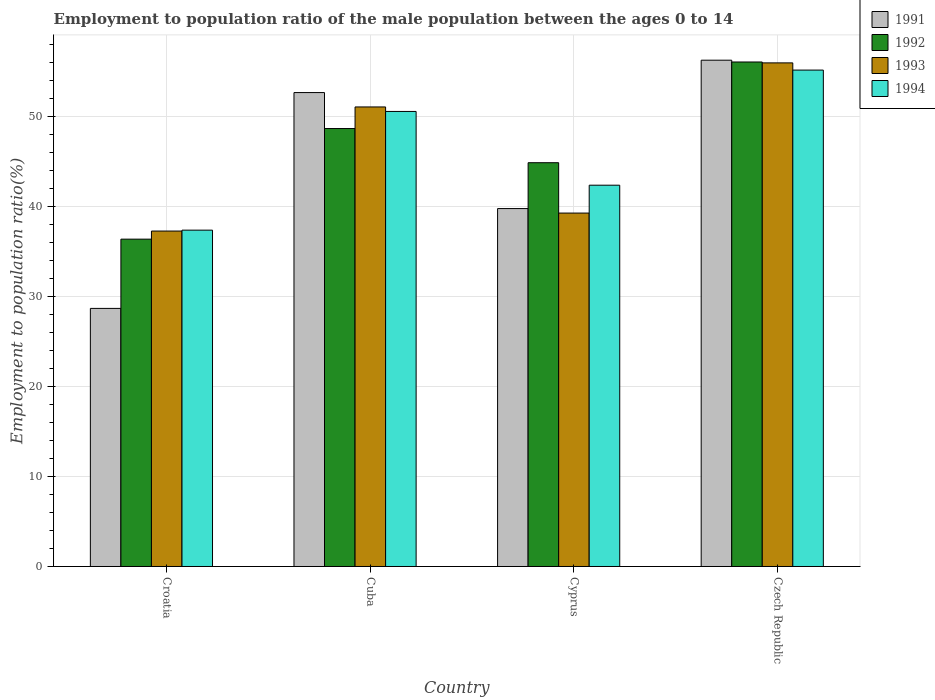How many groups of bars are there?
Your answer should be very brief. 4. Are the number of bars on each tick of the X-axis equal?
Provide a succinct answer. Yes. How many bars are there on the 1st tick from the right?
Offer a terse response. 4. What is the label of the 3rd group of bars from the left?
Offer a very short reply. Cyprus. What is the employment to population ratio in 1993 in Croatia?
Provide a succinct answer. 37.3. Across all countries, what is the maximum employment to population ratio in 1994?
Offer a very short reply. 55.2. Across all countries, what is the minimum employment to population ratio in 1993?
Make the answer very short. 37.3. In which country was the employment to population ratio in 1994 maximum?
Offer a terse response. Czech Republic. In which country was the employment to population ratio in 1993 minimum?
Your answer should be compact. Croatia. What is the total employment to population ratio in 1994 in the graph?
Offer a very short reply. 185.6. What is the difference between the employment to population ratio in 1993 in Cyprus and that in Czech Republic?
Your response must be concise. -16.7. What is the difference between the employment to population ratio in 1994 in Czech Republic and the employment to population ratio in 1991 in Cuba?
Your response must be concise. 2.5. What is the average employment to population ratio in 1992 per country?
Your answer should be very brief. 46.53. What is the difference between the employment to population ratio of/in 1994 and employment to population ratio of/in 1992 in Croatia?
Give a very brief answer. 1. What is the ratio of the employment to population ratio in 1993 in Croatia to that in Cyprus?
Keep it short and to the point. 0.95. Is the employment to population ratio in 1992 in Croatia less than that in Cyprus?
Your answer should be very brief. Yes. Is the difference between the employment to population ratio in 1994 in Cyprus and Czech Republic greater than the difference between the employment to population ratio in 1992 in Cyprus and Czech Republic?
Offer a terse response. No. What is the difference between the highest and the second highest employment to population ratio in 1993?
Provide a short and direct response. 4.9. What is the difference between the highest and the lowest employment to population ratio in 1991?
Provide a succinct answer. 27.6. In how many countries, is the employment to population ratio in 1992 greater than the average employment to population ratio in 1992 taken over all countries?
Your response must be concise. 2. Is it the case that in every country, the sum of the employment to population ratio in 1993 and employment to population ratio in 1994 is greater than the sum of employment to population ratio in 1991 and employment to population ratio in 1992?
Make the answer very short. No. What does the 4th bar from the left in Cyprus represents?
Make the answer very short. 1994. What does the 1st bar from the right in Croatia represents?
Your answer should be compact. 1994. What is the difference between two consecutive major ticks on the Y-axis?
Provide a succinct answer. 10. Does the graph contain any zero values?
Provide a short and direct response. No. How many legend labels are there?
Your answer should be compact. 4. What is the title of the graph?
Your answer should be compact. Employment to population ratio of the male population between the ages 0 to 14. Does "1996" appear as one of the legend labels in the graph?
Ensure brevity in your answer.  No. What is the Employment to population ratio(%) in 1991 in Croatia?
Offer a very short reply. 28.7. What is the Employment to population ratio(%) in 1992 in Croatia?
Provide a short and direct response. 36.4. What is the Employment to population ratio(%) in 1993 in Croatia?
Your answer should be very brief. 37.3. What is the Employment to population ratio(%) of 1994 in Croatia?
Provide a succinct answer. 37.4. What is the Employment to population ratio(%) of 1991 in Cuba?
Provide a succinct answer. 52.7. What is the Employment to population ratio(%) in 1992 in Cuba?
Provide a succinct answer. 48.7. What is the Employment to population ratio(%) in 1993 in Cuba?
Your response must be concise. 51.1. What is the Employment to population ratio(%) of 1994 in Cuba?
Your answer should be compact. 50.6. What is the Employment to population ratio(%) of 1991 in Cyprus?
Your answer should be very brief. 39.8. What is the Employment to population ratio(%) of 1992 in Cyprus?
Give a very brief answer. 44.9. What is the Employment to population ratio(%) in 1993 in Cyprus?
Your answer should be very brief. 39.3. What is the Employment to population ratio(%) in 1994 in Cyprus?
Provide a short and direct response. 42.4. What is the Employment to population ratio(%) in 1991 in Czech Republic?
Provide a short and direct response. 56.3. What is the Employment to population ratio(%) in 1992 in Czech Republic?
Your answer should be compact. 56.1. What is the Employment to population ratio(%) of 1994 in Czech Republic?
Your answer should be very brief. 55.2. Across all countries, what is the maximum Employment to population ratio(%) of 1991?
Make the answer very short. 56.3. Across all countries, what is the maximum Employment to population ratio(%) of 1992?
Your answer should be very brief. 56.1. Across all countries, what is the maximum Employment to population ratio(%) in 1993?
Your answer should be compact. 56. Across all countries, what is the maximum Employment to population ratio(%) in 1994?
Offer a very short reply. 55.2. Across all countries, what is the minimum Employment to population ratio(%) of 1991?
Your response must be concise. 28.7. Across all countries, what is the minimum Employment to population ratio(%) in 1992?
Ensure brevity in your answer.  36.4. Across all countries, what is the minimum Employment to population ratio(%) in 1993?
Offer a terse response. 37.3. Across all countries, what is the minimum Employment to population ratio(%) in 1994?
Provide a succinct answer. 37.4. What is the total Employment to population ratio(%) in 1991 in the graph?
Offer a terse response. 177.5. What is the total Employment to population ratio(%) of 1992 in the graph?
Keep it short and to the point. 186.1. What is the total Employment to population ratio(%) in 1993 in the graph?
Your answer should be compact. 183.7. What is the total Employment to population ratio(%) in 1994 in the graph?
Your response must be concise. 185.6. What is the difference between the Employment to population ratio(%) of 1992 in Croatia and that in Cuba?
Ensure brevity in your answer.  -12.3. What is the difference between the Employment to population ratio(%) of 1993 in Croatia and that in Cuba?
Give a very brief answer. -13.8. What is the difference between the Employment to population ratio(%) of 1994 in Croatia and that in Cyprus?
Give a very brief answer. -5. What is the difference between the Employment to population ratio(%) in 1991 in Croatia and that in Czech Republic?
Make the answer very short. -27.6. What is the difference between the Employment to population ratio(%) in 1992 in Croatia and that in Czech Republic?
Your answer should be very brief. -19.7. What is the difference between the Employment to population ratio(%) of 1993 in Croatia and that in Czech Republic?
Provide a short and direct response. -18.7. What is the difference between the Employment to population ratio(%) of 1994 in Croatia and that in Czech Republic?
Your answer should be compact. -17.8. What is the difference between the Employment to population ratio(%) of 1991 in Cuba and that in Cyprus?
Your response must be concise. 12.9. What is the difference between the Employment to population ratio(%) of 1992 in Cuba and that in Cyprus?
Provide a succinct answer. 3.8. What is the difference between the Employment to population ratio(%) in 1993 in Cuba and that in Cyprus?
Make the answer very short. 11.8. What is the difference between the Employment to population ratio(%) of 1992 in Cuba and that in Czech Republic?
Your response must be concise. -7.4. What is the difference between the Employment to population ratio(%) of 1994 in Cuba and that in Czech Republic?
Your answer should be very brief. -4.6. What is the difference between the Employment to population ratio(%) in 1991 in Cyprus and that in Czech Republic?
Keep it short and to the point. -16.5. What is the difference between the Employment to population ratio(%) of 1992 in Cyprus and that in Czech Republic?
Your answer should be compact. -11.2. What is the difference between the Employment to population ratio(%) of 1993 in Cyprus and that in Czech Republic?
Your answer should be very brief. -16.7. What is the difference between the Employment to population ratio(%) in 1991 in Croatia and the Employment to population ratio(%) in 1993 in Cuba?
Keep it short and to the point. -22.4. What is the difference between the Employment to population ratio(%) in 1991 in Croatia and the Employment to population ratio(%) in 1994 in Cuba?
Keep it short and to the point. -21.9. What is the difference between the Employment to population ratio(%) in 1992 in Croatia and the Employment to population ratio(%) in 1993 in Cuba?
Ensure brevity in your answer.  -14.7. What is the difference between the Employment to population ratio(%) of 1993 in Croatia and the Employment to population ratio(%) of 1994 in Cuba?
Your answer should be compact. -13.3. What is the difference between the Employment to population ratio(%) of 1991 in Croatia and the Employment to population ratio(%) of 1992 in Cyprus?
Your answer should be very brief. -16.2. What is the difference between the Employment to population ratio(%) of 1991 in Croatia and the Employment to population ratio(%) of 1993 in Cyprus?
Provide a short and direct response. -10.6. What is the difference between the Employment to population ratio(%) in 1991 in Croatia and the Employment to population ratio(%) in 1994 in Cyprus?
Offer a terse response. -13.7. What is the difference between the Employment to population ratio(%) of 1992 in Croatia and the Employment to population ratio(%) of 1994 in Cyprus?
Keep it short and to the point. -6. What is the difference between the Employment to population ratio(%) in 1991 in Croatia and the Employment to population ratio(%) in 1992 in Czech Republic?
Offer a terse response. -27.4. What is the difference between the Employment to population ratio(%) of 1991 in Croatia and the Employment to population ratio(%) of 1993 in Czech Republic?
Offer a very short reply. -27.3. What is the difference between the Employment to population ratio(%) in 1991 in Croatia and the Employment to population ratio(%) in 1994 in Czech Republic?
Give a very brief answer. -26.5. What is the difference between the Employment to population ratio(%) in 1992 in Croatia and the Employment to population ratio(%) in 1993 in Czech Republic?
Your response must be concise. -19.6. What is the difference between the Employment to population ratio(%) in 1992 in Croatia and the Employment to population ratio(%) in 1994 in Czech Republic?
Ensure brevity in your answer.  -18.8. What is the difference between the Employment to population ratio(%) in 1993 in Croatia and the Employment to population ratio(%) in 1994 in Czech Republic?
Your answer should be compact. -17.9. What is the difference between the Employment to population ratio(%) of 1991 in Cuba and the Employment to population ratio(%) of 1994 in Cyprus?
Give a very brief answer. 10.3. What is the difference between the Employment to population ratio(%) in 1992 in Cuba and the Employment to population ratio(%) in 1994 in Cyprus?
Keep it short and to the point. 6.3. What is the difference between the Employment to population ratio(%) of 1993 in Cuba and the Employment to population ratio(%) of 1994 in Cyprus?
Provide a succinct answer. 8.7. What is the difference between the Employment to population ratio(%) in 1991 in Cuba and the Employment to population ratio(%) in 1994 in Czech Republic?
Make the answer very short. -2.5. What is the difference between the Employment to population ratio(%) in 1992 in Cuba and the Employment to population ratio(%) in 1993 in Czech Republic?
Provide a succinct answer. -7.3. What is the difference between the Employment to population ratio(%) in 1992 in Cuba and the Employment to population ratio(%) in 1994 in Czech Republic?
Give a very brief answer. -6.5. What is the difference between the Employment to population ratio(%) in 1993 in Cuba and the Employment to population ratio(%) in 1994 in Czech Republic?
Provide a succinct answer. -4.1. What is the difference between the Employment to population ratio(%) in 1991 in Cyprus and the Employment to population ratio(%) in 1992 in Czech Republic?
Offer a very short reply. -16.3. What is the difference between the Employment to population ratio(%) in 1991 in Cyprus and the Employment to population ratio(%) in 1993 in Czech Republic?
Make the answer very short. -16.2. What is the difference between the Employment to population ratio(%) in 1991 in Cyprus and the Employment to population ratio(%) in 1994 in Czech Republic?
Offer a terse response. -15.4. What is the difference between the Employment to population ratio(%) in 1992 in Cyprus and the Employment to population ratio(%) in 1993 in Czech Republic?
Your response must be concise. -11.1. What is the difference between the Employment to population ratio(%) in 1993 in Cyprus and the Employment to population ratio(%) in 1994 in Czech Republic?
Your answer should be compact. -15.9. What is the average Employment to population ratio(%) of 1991 per country?
Provide a succinct answer. 44.38. What is the average Employment to population ratio(%) in 1992 per country?
Provide a succinct answer. 46.52. What is the average Employment to population ratio(%) in 1993 per country?
Provide a succinct answer. 45.92. What is the average Employment to population ratio(%) of 1994 per country?
Provide a short and direct response. 46.4. What is the difference between the Employment to population ratio(%) in 1991 and Employment to population ratio(%) in 1993 in Croatia?
Your answer should be compact. -8.6. What is the difference between the Employment to population ratio(%) of 1992 and Employment to population ratio(%) of 1994 in Croatia?
Your answer should be compact. -1. What is the difference between the Employment to population ratio(%) in 1991 and Employment to population ratio(%) in 1993 in Cuba?
Keep it short and to the point. 1.6. What is the difference between the Employment to population ratio(%) of 1992 and Employment to population ratio(%) of 1994 in Cuba?
Your answer should be very brief. -1.9. What is the difference between the Employment to population ratio(%) of 1991 and Employment to population ratio(%) of 1992 in Cyprus?
Give a very brief answer. -5.1. What is the difference between the Employment to population ratio(%) of 1991 and Employment to population ratio(%) of 1993 in Cyprus?
Provide a succinct answer. 0.5. What is the difference between the Employment to population ratio(%) of 1992 and Employment to population ratio(%) of 1993 in Cyprus?
Your answer should be compact. 5.6. What is the difference between the Employment to population ratio(%) of 1991 and Employment to population ratio(%) of 1992 in Czech Republic?
Make the answer very short. 0.2. What is the difference between the Employment to population ratio(%) of 1991 and Employment to population ratio(%) of 1993 in Czech Republic?
Your answer should be compact. 0.3. What is the difference between the Employment to population ratio(%) of 1991 and Employment to population ratio(%) of 1994 in Czech Republic?
Give a very brief answer. 1.1. What is the difference between the Employment to population ratio(%) of 1992 and Employment to population ratio(%) of 1993 in Czech Republic?
Your answer should be very brief. 0.1. What is the difference between the Employment to population ratio(%) in 1992 and Employment to population ratio(%) in 1994 in Czech Republic?
Provide a short and direct response. 0.9. What is the difference between the Employment to population ratio(%) of 1993 and Employment to population ratio(%) of 1994 in Czech Republic?
Ensure brevity in your answer.  0.8. What is the ratio of the Employment to population ratio(%) of 1991 in Croatia to that in Cuba?
Provide a short and direct response. 0.54. What is the ratio of the Employment to population ratio(%) of 1992 in Croatia to that in Cuba?
Give a very brief answer. 0.75. What is the ratio of the Employment to population ratio(%) of 1993 in Croatia to that in Cuba?
Offer a terse response. 0.73. What is the ratio of the Employment to population ratio(%) in 1994 in Croatia to that in Cuba?
Provide a short and direct response. 0.74. What is the ratio of the Employment to population ratio(%) in 1991 in Croatia to that in Cyprus?
Offer a very short reply. 0.72. What is the ratio of the Employment to population ratio(%) of 1992 in Croatia to that in Cyprus?
Offer a very short reply. 0.81. What is the ratio of the Employment to population ratio(%) of 1993 in Croatia to that in Cyprus?
Offer a very short reply. 0.95. What is the ratio of the Employment to population ratio(%) of 1994 in Croatia to that in Cyprus?
Your answer should be very brief. 0.88. What is the ratio of the Employment to population ratio(%) of 1991 in Croatia to that in Czech Republic?
Offer a very short reply. 0.51. What is the ratio of the Employment to population ratio(%) in 1992 in Croatia to that in Czech Republic?
Offer a very short reply. 0.65. What is the ratio of the Employment to population ratio(%) of 1993 in Croatia to that in Czech Republic?
Your answer should be very brief. 0.67. What is the ratio of the Employment to population ratio(%) of 1994 in Croatia to that in Czech Republic?
Your answer should be very brief. 0.68. What is the ratio of the Employment to population ratio(%) of 1991 in Cuba to that in Cyprus?
Your answer should be very brief. 1.32. What is the ratio of the Employment to population ratio(%) in 1992 in Cuba to that in Cyprus?
Provide a short and direct response. 1.08. What is the ratio of the Employment to population ratio(%) in 1993 in Cuba to that in Cyprus?
Provide a short and direct response. 1.3. What is the ratio of the Employment to population ratio(%) of 1994 in Cuba to that in Cyprus?
Your answer should be compact. 1.19. What is the ratio of the Employment to population ratio(%) in 1991 in Cuba to that in Czech Republic?
Offer a very short reply. 0.94. What is the ratio of the Employment to population ratio(%) of 1992 in Cuba to that in Czech Republic?
Offer a very short reply. 0.87. What is the ratio of the Employment to population ratio(%) in 1993 in Cuba to that in Czech Republic?
Provide a short and direct response. 0.91. What is the ratio of the Employment to population ratio(%) of 1991 in Cyprus to that in Czech Republic?
Your response must be concise. 0.71. What is the ratio of the Employment to population ratio(%) in 1992 in Cyprus to that in Czech Republic?
Give a very brief answer. 0.8. What is the ratio of the Employment to population ratio(%) in 1993 in Cyprus to that in Czech Republic?
Your answer should be very brief. 0.7. What is the ratio of the Employment to population ratio(%) of 1994 in Cyprus to that in Czech Republic?
Provide a succinct answer. 0.77. What is the difference between the highest and the second highest Employment to population ratio(%) of 1991?
Ensure brevity in your answer.  3.6. What is the difference between the highest and the second highest Employment to population ratio(%) in 1992?
Keep it short and to the point. 7.4. What is the difference between the highest and the second highest Employment to population ratio(%) of 1994?
Ensure brevity in your answer.  4.6. What is the difference between the highest and the lowest Employment to population ratio(%) of 1991?
Ensure brevity in your answer.  27.6. What is the difference between the highest and the lowest Employment to population ratio(%) of 1993?
Keep it short and to the point. 18.7. What is the difference between the highest and the lowest Employment to population ratio(%) of 1994?
Give a very brief answer. 17.8. 